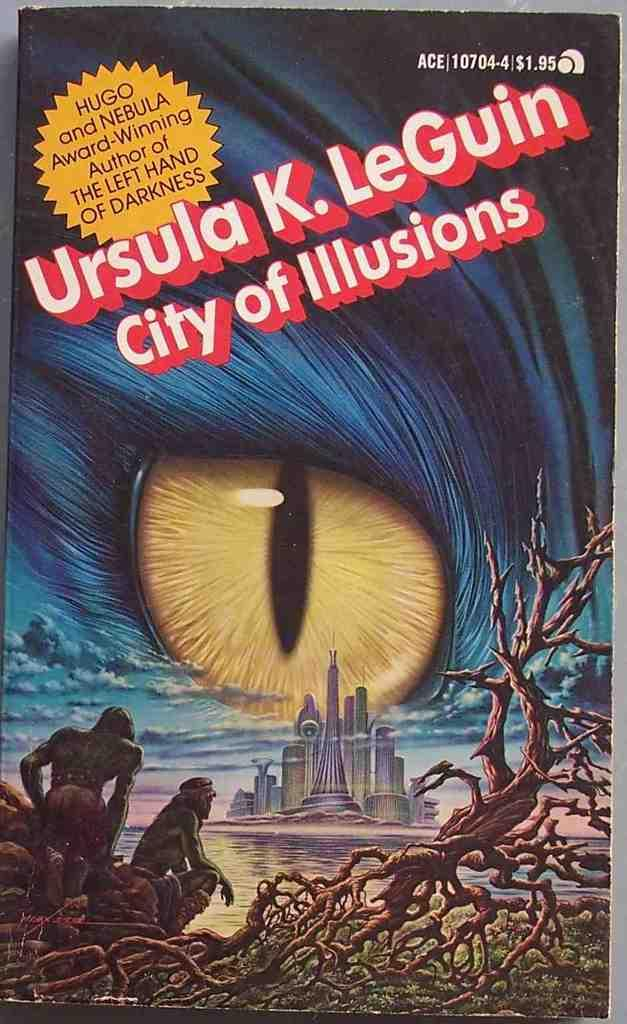<image>
Give a short and clear explanation of the subsequent image. The author of City of Illusions is a Hugo award winner. 